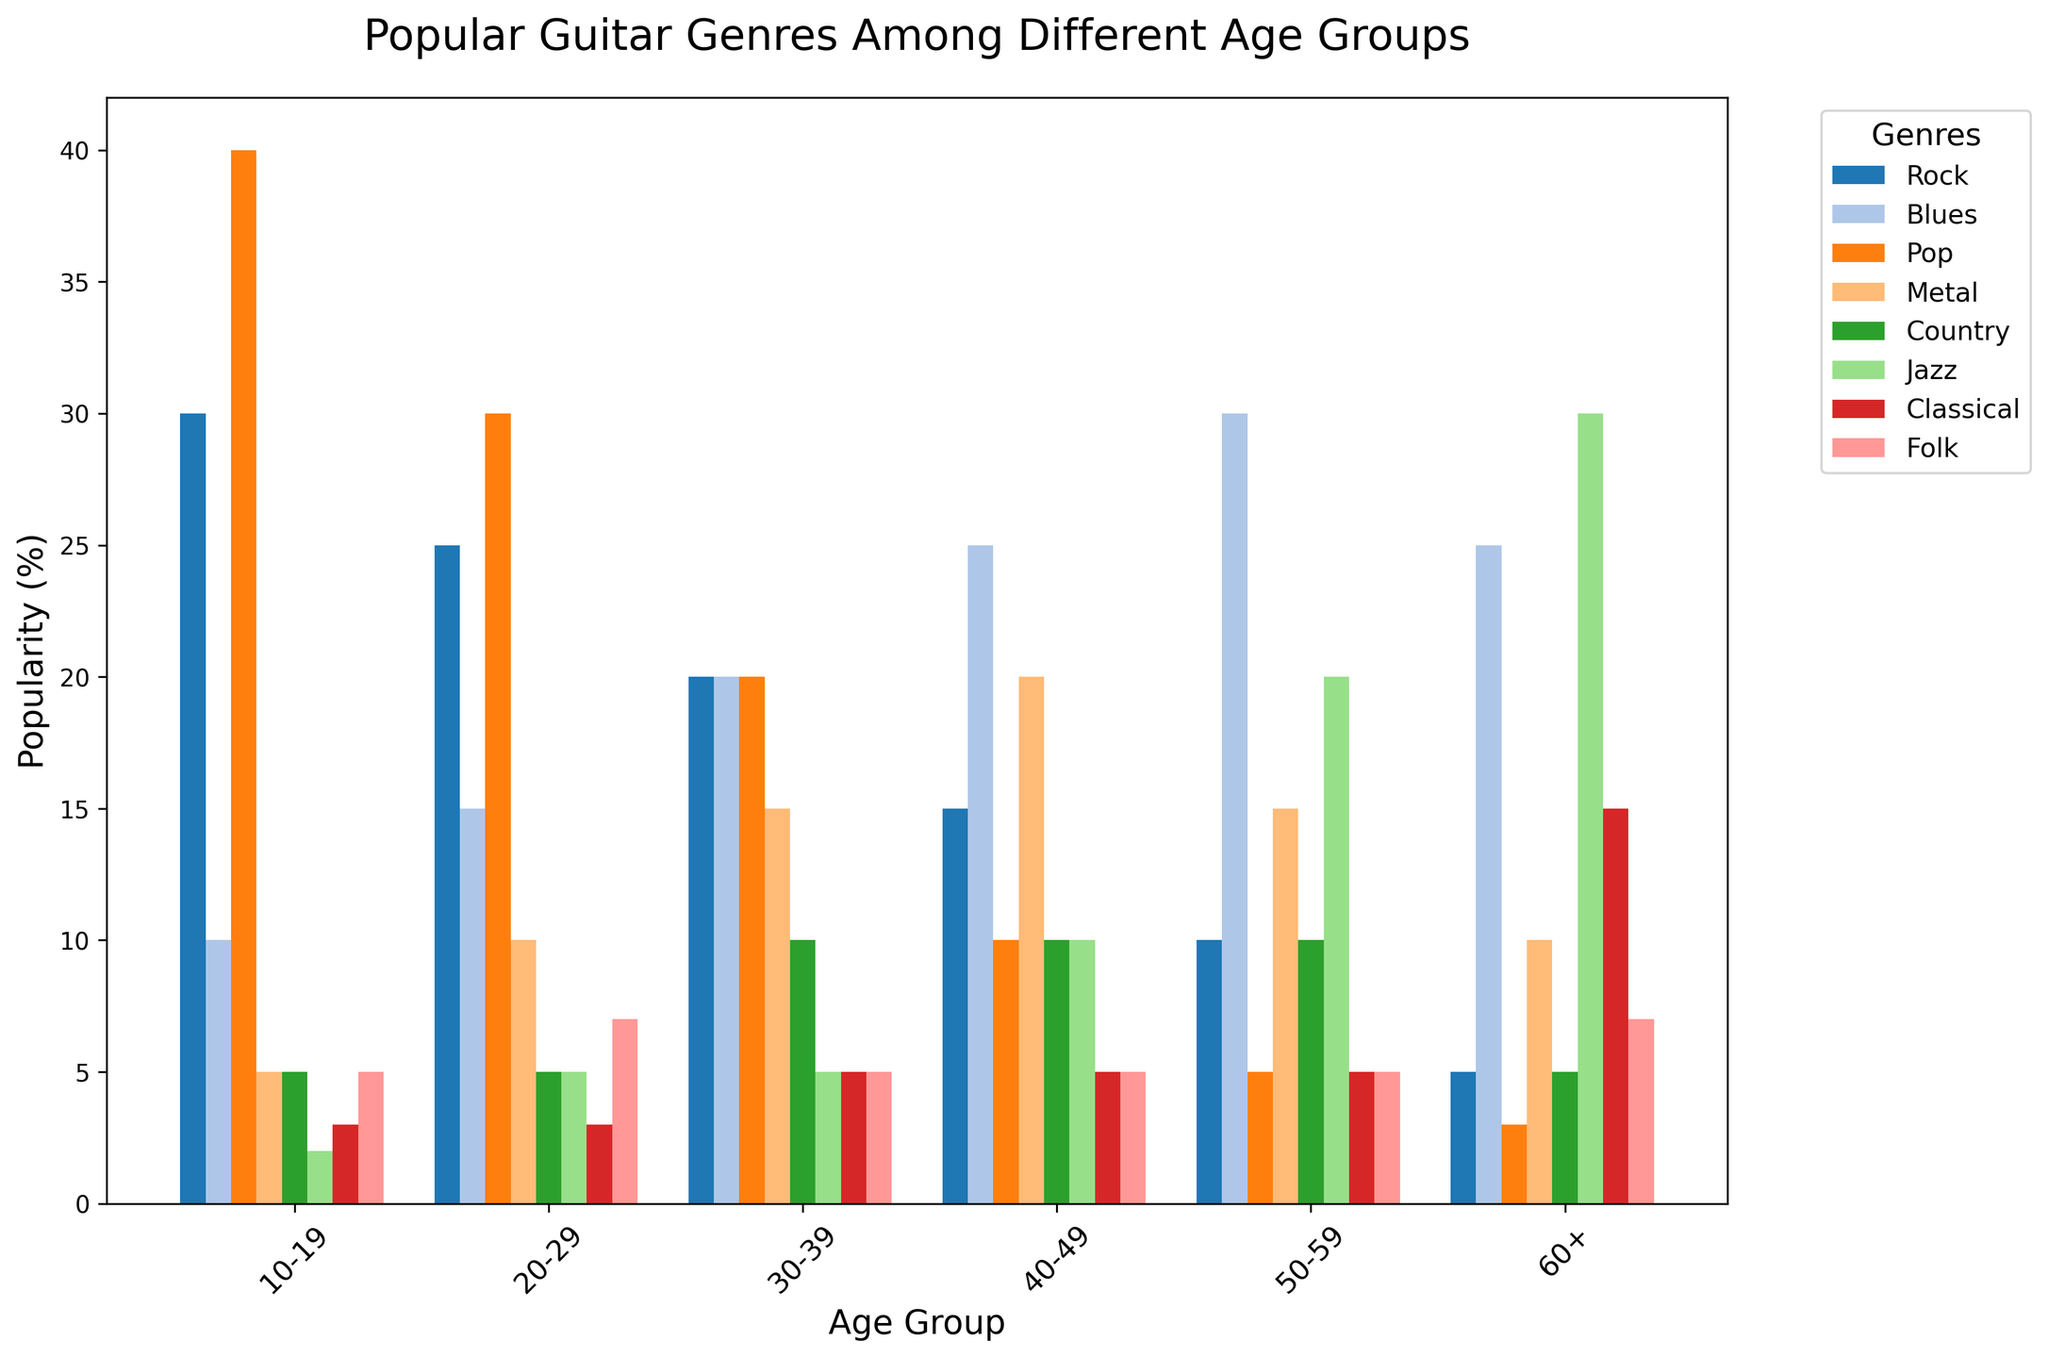How many age groups have Rock as a more popular genre than Metal? To determine this, compare the Rock and Metal bars for each age group. Rock is more popular than Metal in the 10-19, 20-29, and 30-39 age groups.
Answer: 3 Which genre is the most popular among the 50-59 age group? Check the bar heights for each genre within the 50-59 age group. The highest bar is for Blues with a value of 30.
Answer: Blues What is the combined popularity of Jazz across all age groups? Sum the Jazz values for all age groups: 2 + 5 + 5 + 10 + 20 + 30 = 72.
Answer: 72 In which age group is Classical music the least popular, and what is its value? Locate the shortest bar for Classical across all age groups, which is in the 10-19 age group with a value of 3.
Answer: 10-19, 3 Compare the popularity of Pop between the 20-29 and 40-49 age groups. Which has a higher value, and by how much? The Pop value for 20-29 is 30, and for 40-49 is 10. The 20-29 age group has a higher value by 20.
Answer: 20-29 by 20 What is the average popularity of Folk music across all age groups? Sum the Folk values: 5 + 7 + 5 + 5 + 5 + 7 = 34. Divide by the number of age groups: 34 / 6 ≈ 5.67.
Answer: ≈ 5.67 Which age group has the highest preference for Metal music? Look for the age group with the tallest Metal bar, which is the 40-49 age group with a value of 20.
Answer: 40-49 What is the difference in popularity between Rock and Classical music in the 30-39 age group? The Rock value for 30-39 is 20, and the Classical value is 5. The difference is 20 - 5 = 15.
Answer: 15 Identify the second most popular genre in the 60+ age group. In the 60+ age group, the highest bar is Jazz (30), and the second highest is Classical (15).
Answer: Classical Compare the popularity of Country music between the 40-49 and 60+ age groups. Which age group has a higher value, and by how much? The Country value for 40-49 is 10, and for the 60+ age group is 5. The 40-49 age group has a higher value by 5.
Answer: 40-49 by 5 